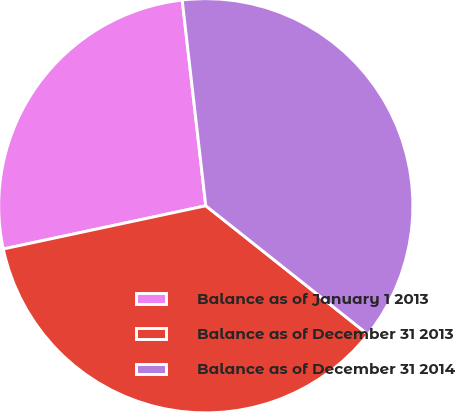Convert chart to OTSL. <chart><loc_0><loc_0><loc_500><loc_500><pie_chart><fcel>Balance as of January 1 2013<fcel>Balance as of December 31 2013<fcel>Balance as of December 31 2014<nl><fcel>26.53%<fcel>35.98%<fcel>37.49%<nl></chart> 